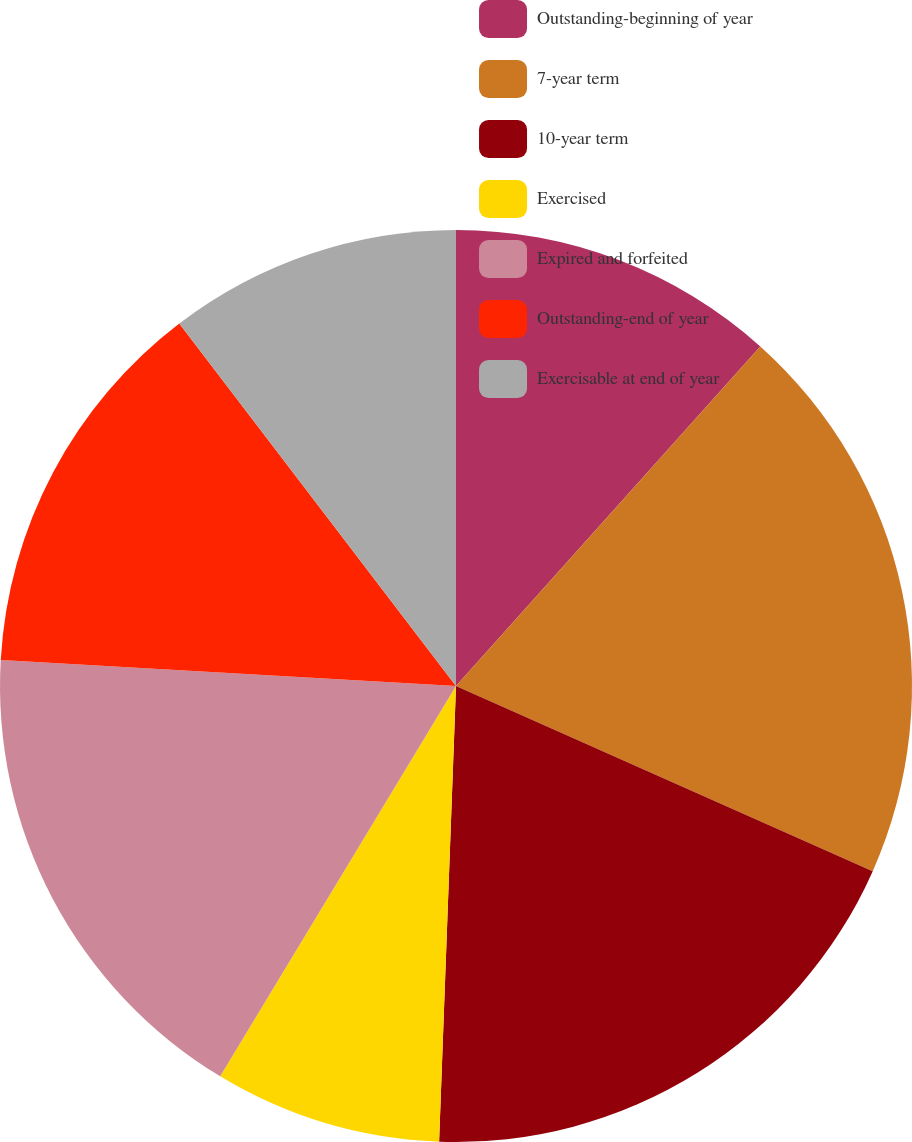<chart> <loc_0><loc_0><loc_500><loc_500><pie_chart><fcel>Outstanding-beginning of year<fcel>7-year term<fcel>10-year term<fcel>Exercised<fcel>Expired and forfeited<fcel>Outstanding-end of year<fcel>Exercisable at end of year<nl><fcel>11.63%<fcel>20.03%<fcel>18.94%<fcel>8.06%<fcel>17.26%<fcel>13.72%<fcel>10.38%<nl></chart> 